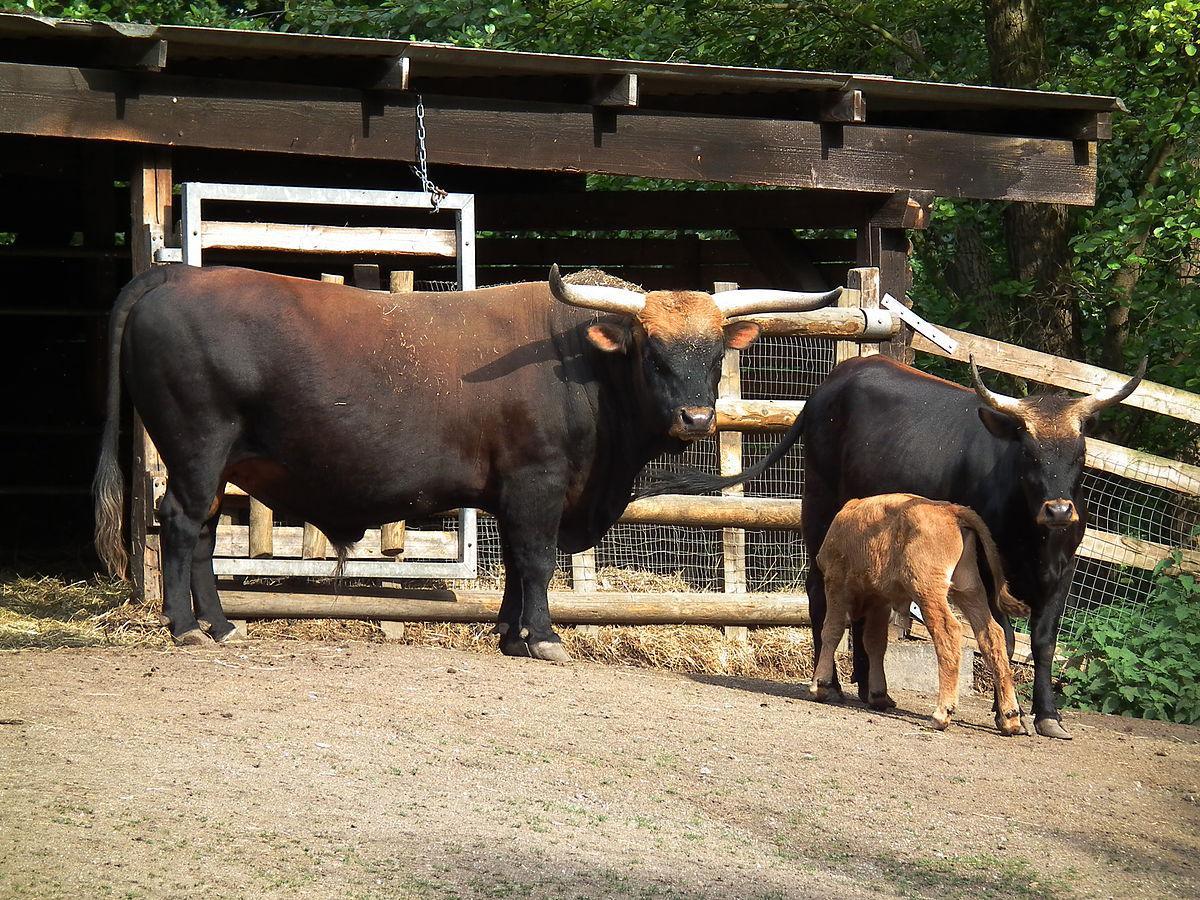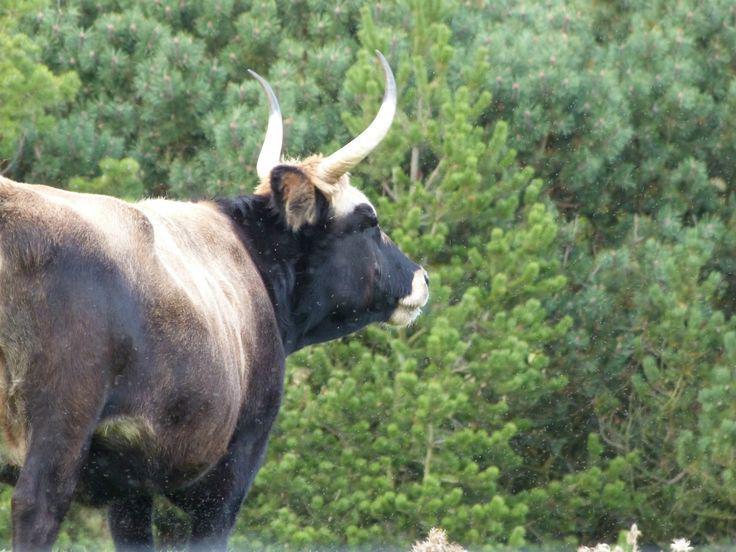The first image is the image on the left, the second image is the image on the right. Analyze the images presented: Is the assertion "One image includes at least two cattle." valid? Answer yes or no. Yes. 